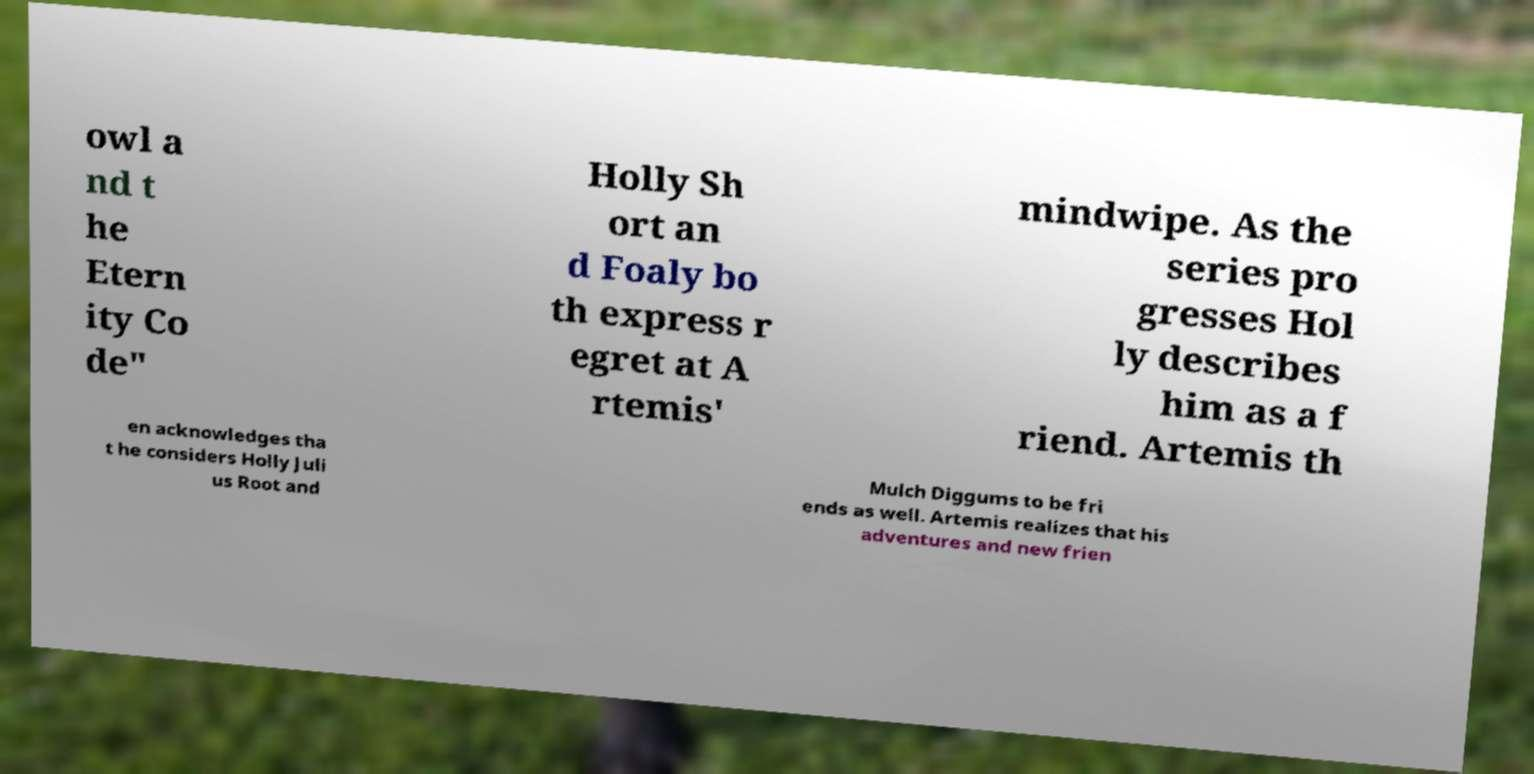Could you extract and type out the text from this image? owl a nd t he Etern ity Co de" Holly Sh ort an d Foaly bo th express r egret at A rtemis' mindwipe. As the series pro gresses Hol ly describes him as a f riend. Artemis th en acknowledges tha t he considers Holly Juli us Root and Mulch Diggums to be fri ends as well. Artemis realizes that his adventures and new frien 